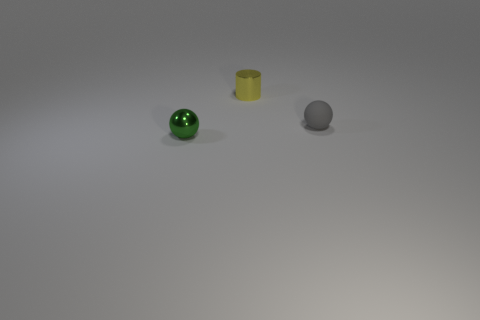There is an object that is both in front of the tiny yellow object and to the left of the tiny rubber ball; what is its shape? The object that is located both in front of the tiny yellow cylinder and to the left of the tiny rubber ball is shaped like a sphere. 